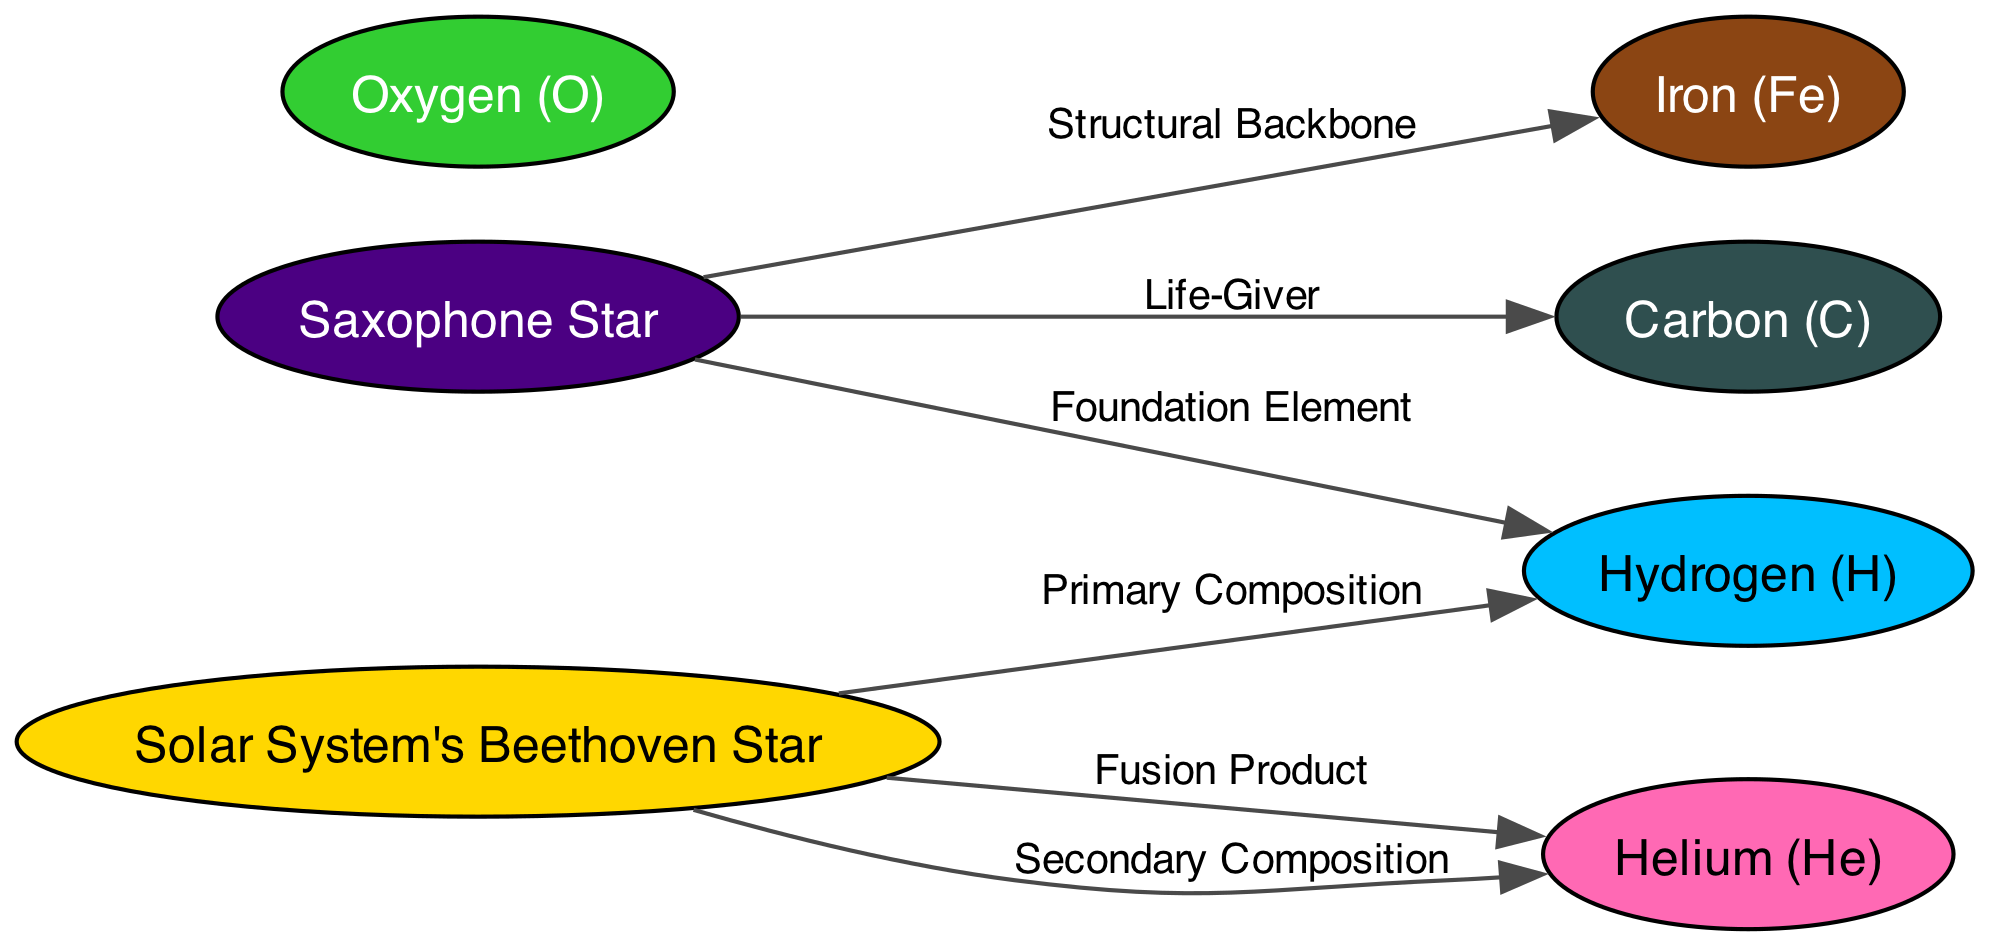What's the primary composition of the Solar System's Beethoven Star? The diagram states that the Solar System's Beethoven Star is composed mostly of hydrogen, indicating it's the primary element found in this star.
Answer: Hydrogen Which star contains carbon? According to the diagram, carbon is shown to be a connection from the Saxophone Star, confirming that this star contains carbon in its composition.
Answer: Saxophone Star How many edges are connected to the Saxophone Star? Looking at the diagram, the Saxophone Star has two outgoing edges connecting it to both carbon and iron, which gives us a total of two edges.
Answer: 2 What is the role of iron in the Saxophone Star? As per the edge description linked to iron, it states that iron maintains the core stability of the Saxophone Star, serving as its structural backbone.
Answer: Structural Backbone Which element acts as the foundation element for both stars? The diagram indicates that hydrogen serves as the foundational element for both the Solar System's Beethoven Star and the Saxophone Star, reinforcing its fundamental role in star composition.
Answer: Hydrogen What secondary element is mentioned for the Solar System's Beethoven Star? The diagram points out that helium is a secondary composition in the Solar System's Beethoven Star, derived from hydrogen fusion, making it the answer.
Answer: Helium How is the Saxophone Star described in terms of creativity? The description attached to the Saxophone Star characterizes it as embodying "the essence of improvisational creativity," highlighting its association with creativity in cosmic events.
Answer: Improvisational Creativity How many total nodes are present in the diagram? To find the total number of nodes, we count each individual element listed in the data. There are seven nodes depicted in the diagram.
Answer: 7 What element is vital for life as we know it? The diagram shows that oxygen is described as vital for life, emphasizing its importance in both biology and stellar processes.
Answer: Oxygen 